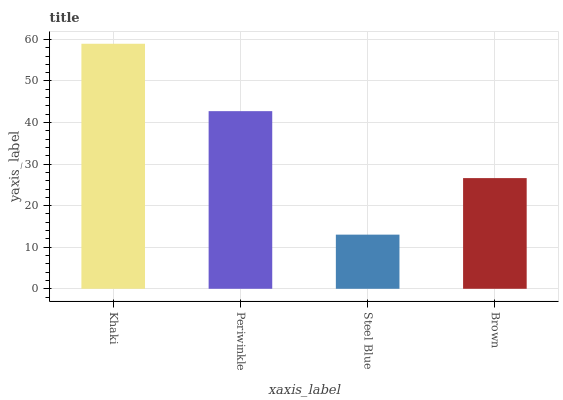Is Steel Blue the minimum?
Answer yes or no. Yes. Is Khaki the maximum?
Answer yes or no. Yes. Is Periwinkle the minimum?
Answer yes or no. No. Is Periwinkle the maximum?
Answer yes or no. No. Is Khaki greater than Periwinkle?
Answer yes or no. Yes. Is Periwinkle less than Khaki?
Answer yes or no. Yes. Is Periwinkle greater than Khaki?
Answer yes or no. No. Is Khaki less than Periwinkle?
Answer yes or no. No. Is Periwinkle the high median?
Answer yes or no. Yes. Is Brown the low median?
Answer yes or no. Yes. Is Brown the high median?
Answer yes or no. No. Is Periwinkle the low median?
Answer yes or no. No. 